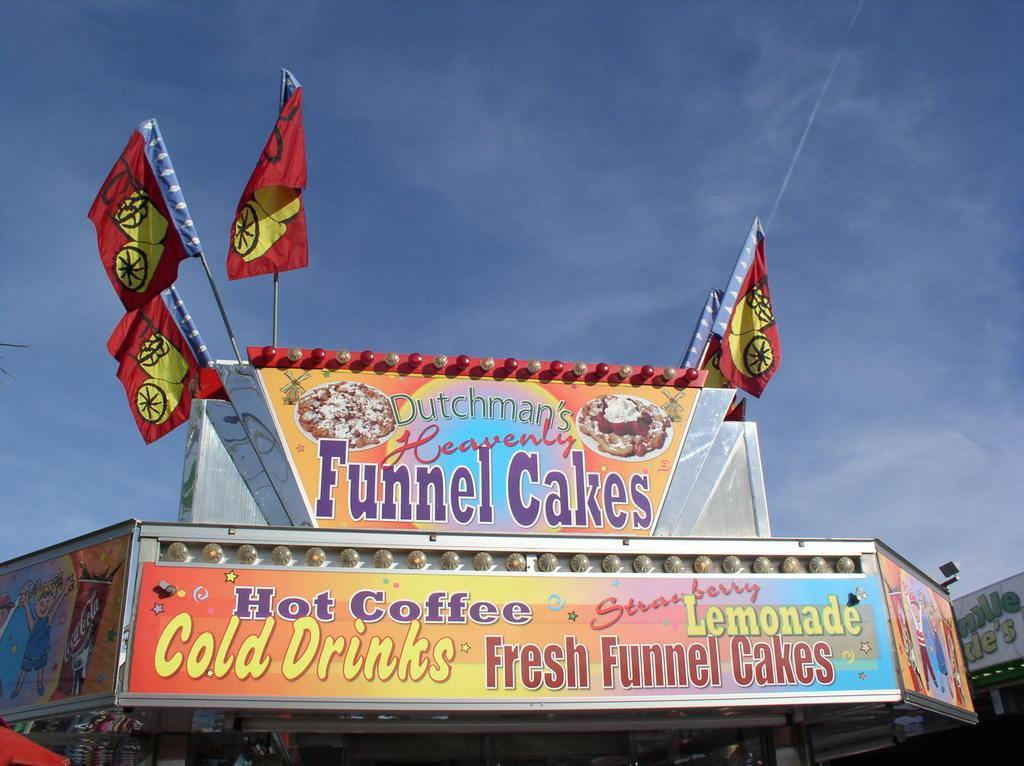Could you give a brief overview of what you see in this image? In this image I can see two boards in multi color and I can also see two flags in red and yellow color. Background the sky is in blue and white color. 